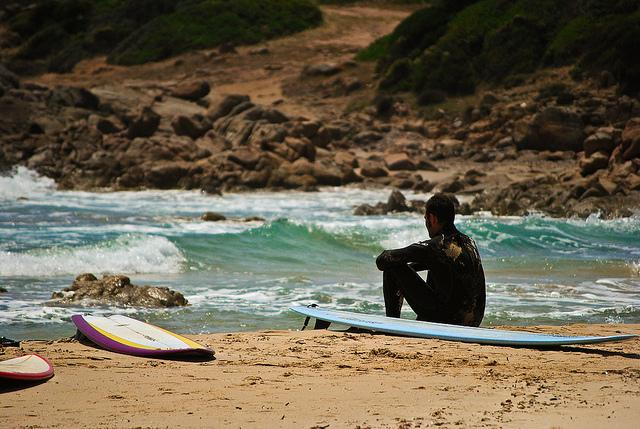What was the man just doing?

Choices:
A) swimming
B) lying down
C) running
D) sunbathing lying down 